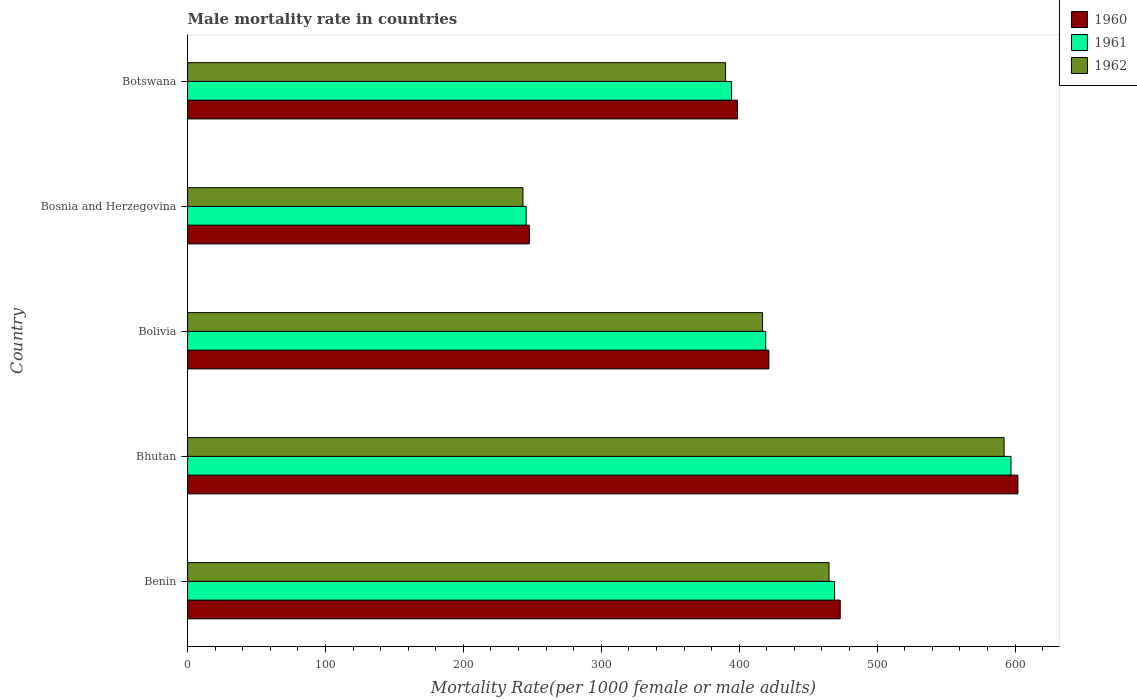Are the number of bars per tick equal to the number of legend labels?
Offer a terse response. Yes. How many bars are there on the 2nd tick from the top?
Ensure brevity in your answer.  3. What is the label of the 3rd group of bars from the top?
Give a very brief answer. Bolivia. What is the male mortality rate in 1961 in Benin?
Offer a terse response. 469.18. Across all countries, what is the maximum male mortality rate in 1961?
Your answer should be very brief. 597.09. Across all countries, what is the minimum male mortality rate in 1961?
Make the answer very short. 245.51. In which country was the male mortality rate in 1961 maximum?
Your response must be concise. Bhutan. In which country was the male mortality rate in 1960 minimum?
Provide a succinct answer. Bosnia and Herzegovina. What is the total male mortality rate in 1962 in the graph?
Your response must be concise. 2107.42. What is the difference between the male mortality rate in 1962 in Bhutan and that in Bolivia?
Provide a succinct answer. 175.15. What is the difference between the male mortality rate in 1960 in Bolivia and the male mortality rate in 1961 in Benin?
Offer a terse response. -47.68. What is the average male mortality rate in 1962 per country?
Provide a short and direct response. 421.48. What is the difference between the male mortality rate in 1962 and male mortality rate in 1960 in Botswana?
Provide a short and direct response. -8.61. What is the ratio of the male mortality rate in 1961 in Bolivia to that in Bosnia and Herzegovina?
Keep it short and to the point. 1.71. Is the difference between the male mortality rate in 1962 in Benin and Bosnia and Herzegovina greater than the difference between the male mortality rate in 1960 in Benin and Bosnia and Herzegovina?
Provide a succinct answer. No. What is the difference between the highest and the second highest male mortality rate in 1962?
Offer a terse response. 126.96. What is the difference between the highest and the lowest male mortality rate in 1960?
Your response must be concise. 354.26. In how many countries, is the male mortality rate in 1961 greater than the average male mortality rate in 1961 taken over all countries?
Provide a short and direct response. 2. What does the 1st bar from the bottom in Bolivia represents?
Give a very brief answer. 1960. How many countries are there in the graph?
Provide a succinct answer. 5. Are the values on the major ticks of X-axis written in scientific E-notation?
Make the answer very short. No. How many legend labels are there?
Provide a succinct answer. 3. What is the title of the graph?
Provide a short and direct response. Male mortality rate in countries. Does "1986" appear as one of the legend labels in the graph?
Give a very brief answer. No. What is the label or title of the X-axis?
Your answer should be very brief. Mortality Rate(per 1000 female or male adults). What is the Mortality Rate(per 1000 female or male adults) in 1960 in Benin?
Offer a terse response. 473.24. What is the Mortality Rate(per 1000 female or male adults) of 1961 in Benin?
Make the answer very short. 469.18. What is the Mortality Rate(per 1000 female or male adults) of 1962 in Benin?
Your answer should be very brief. 465.12. What is the Mortality Rate(per 1000 female or male adults) of 1960 in Bhutan?
Offer a very short reply. 602.1. What is the Mortality Rate(per 1000 female or male adults) in 1961 in Bhutan?
Keep it short and to the point. 597.09. What is the Mortality Rate(per 1000 female or male adults) in 1962 in Bhutan?
Give a very brief answer. 592.08. What is the Mortality Rate(per 1000 female or male adults) in 1960 in Bolivia?
Your answer should be very brief. 421.5. What is the Mortality Rate(per 1000 female or male adults) of 1961 in Bolivia?
Keep it short and to the point. 419.21. What is the Mortality Rate(per 1000 female or male adults) in 1962 in Bolivia?
Ensure brevity in your answer.  416.93. What is the Mortality Rate(per 1000 female or male adults) of 1960 in Bosnia and Herzegovina?
Provide a short and direct response. 247.84. What is the Mortality Rate(per 1000 female or male adults) of 1961 in Bosnia and Herzegovina?
Give a very brief answer. 245.51. What is the Mortality Rate(per 1000 female or male adults) of 1962 in Bosnia and Herzegovina?
Your response must be concise. 243.18. What is the Mortality Rate(per 1000 female or male adults) in 1960 in Botswana?
Your response must be concise. 398.72. What is the Mortality Rate(per 1000 female or male adults) of 1961 in Botswana?
Provide a succinct answer. 394.41. What is the Mortality Rate(per 1000 female or male adults) in 1962 in Botswana?
Provide a short and direct response. 390.11. Across all countries, what is the maximum Mortality Rate(per 1000 female or male adults) in 1960?
Give a very brief answer. 602.1. Across all countries, what is the maximum Mortality Rate(per 1000 female or male adults) in 1961?
Give a very brief answer. 597.09. Across all countries, what is the maximum Mortality Rate(per 1000 female or male adults) in 1962?
Provide a short and direct response. 592.08. Across all countries, what is the minimum Mortality Rate(per 1000 female or male adults) in 1960?
Your response must be concise. 247.84. Across all countries, what is the minimum Mortality Rate(per 1000 female or male adults) of 1961?
Offer a terse response. 245.51. Across all countries, what is the minimum Mortality Rate(per 1000 female or male adults) in 1962?
Your answer should be compact. 243.18. What is the total Mortality Rate(per 1000 female or male adults) of 1960 in the graph?
Your answer should be very brief. 2143.39. What is the total Mortality Rate(per 1000 female or male adults) of 1961 in the graph?
Offer a very short reply. 2125.41. What is the total Mortality Rate(per 1000 female or male adults) of 1962 in the graph?
Keep it short and to the point. 2107.42. What is the difference between the Mortality Rate(per 1000 female or male adults) in 1960 in Benin and that in Bhutan?
Keep it short and to the point. -128.86. What is the difference between the Mortality Rate(per 1000 female or male adults) in 1961 in Benin and that in Bhutan?
Your answer should be very brief. -127.91. What is the difference between the Mortality Rate(per 1000 female or male adults) in 1962 in Benin and that in Bhutan?
Offer a very short reply. -126.96. What is the difference between the Mortality Rate(per 1000 female or male adults) of 1960 in Benin and that in Bolivia?
Give a very brief answer. 51.73. What is the difference between the Mortality Rate(per 1000 female or male adults) in 1961 in Benin and that in Bolivia?
Your answer should be compact. 49.97. What is the difference between the Mortality Rate(per 1000 female or male adults) in 1962 in Benin and that in Bolivia?
Your answer should be very brief. 48.2. What is the difference between the Mortality Rate(per 1000 female or male adults) of 1960 in Benin and that in Bosnia and Herzegovina?
Your answer should be compact. 225.4. What is the difference between the Mortality Rate(per 1000 female or male adults) of 1961 in Benin and that in Bosnia and Herzegovina?
Give a very brief answer. 223.67. What is the difference between the Mortality Rate(per 1000 female or male adults) of 1962 in Benin and that in Bosnia and Herzegovina?
Make the answer very short. 221.94. What is the difference between the Mortality Rate(per 1000 female or male adults) of 1960 in Benin and that in Botswana?
Offer a very short reply. 74.52. What is the difference between the Mortality Rate(per 1000 female or male adults) of 1961 in Benin and that in Botswana?
Make the answer very short. 74.77. What is the difference between the Mortality Rate(per 1000 female or male adults) of 1962 in Benin and that in Botswana?
Your answer should be compact. 75.02. What is the difference between the Mortality Rate(per 1000 female or male adults) of 1960 in Bhutan and that in Bolivia?
Keep it short and to the point. 180.59. What is the difference between the Mortality Rate(per 1000 female or male adults) in 1961 in Bhutan and that in Bolivia?
Your answer should be very brief. 177.87. What is the difference between the Mortality Rate(per 1000 female or male adults) of 1962 in Bhutan and that in Bolivia?
Your response must be concise. 175.15. What is the difference between the Mortality Rate(per 1000 female or male adults) of 1960 in Bhutan and that in Bosnia and Herzegovina?
Provide a succinct answer. 354.26. What is the difference between the Mortality Rate(per 1000 female or male adults) in 1961 in Bhutan and that in Bosnia and Herzegovina?
Your answer should be very brief. 351.58. What is the difference between the Mortality Rate(per 1000 female or male adults) of 1962 in Bhutan and that in Bosnia and Herzegovina?
Offer a very short reply. 348.9. What is the difference between the Mortality Rate(per 1000 female or male adults) in 1960 in Bhutan and that in Botswana?
Provide a short and direct response. 203.38. What is the difference between the Mortality Rate(per 1000 female or male adults) in 1961 in Bhutan and that in Botswana?
Offer a terse response. 202.68. What is the difference between the Mortality Rate(per 1000 female or male adults) of 1962 in Bhutan and that in Botswana?
Your response must be concise. 201.97. What is the difference between the Mortality Rate(per 1000 female or male adults) in 1960 in Bolivia and that in Bosnia and Herzegovina?
Ensure brevity in your answer.  173.66. What is the difference between the Mortality Rate(per 1000 female or male adults) in 1961 in Bolivia and that in Bosnia and Herzegovina?
Give a very brief answer. 173.71. What is the difference between the Mortality Rate(per 1000 female or male adults) of 1962 in Bolivia and that in Bosnia and Herzegovina?
Ensure brevity in your answer.  173.75. What is the difference between the Mortality Rate(per 1000 female or male adults) in 1960 in Bolivia and that in Botswana?
Offer a very short reply. 22.79. What is the difference between the Mortality Rate(per 1000 female or male adults) in 1961 in Bolivia and that in Botswana?
Your response must be concise. 24.8. What is the difference between the Mortality Rate(per 1000 female or male adults) of 1962 in Bolivia and that in Botswana?
Make the answer very short. 26.82. What is the difference between the Mortality Rate(per 1000 female or male adults) in 1960 in Bosnia and Herzegovina and that in Botswana?
Give a very brief answer. -150.88. What is the difference between the Mortality Rate(per 1000 female or male adults) of 1961 in Bosnia and Herzegovina and that in Botswana?
Your response must be concise. -148.9. What is the difference between the Mortality Rate(per 1000 female or male adults) of 1962 in Bosnia and Herzegovina and that in Botswana?
Offer a terse response. -146.93. What is the difference between the Mortality Rate(per 1000 female or male adults) in 1960 in Benin and the Mortality Rate(per 1000 female or male adults) in 1961 in Bhutan?
Ensure brevity in your answer.  -123.85. What is the difference between the Mortality Rate(per 1000 female or male adults) of 1960 in Benin and the Mortality Rate(per 1000 female or male adults) of 1962 in Bhutan?
Offer a terse response. -118.84. What is the difference between the Mortality Rate(per 1000 female or male adults) of 1961 in Benin and the Mortality Rate(per 1000 female or male adults) of 1962 in Bhutan?
Give a very brief answer. -122.9. What is the difference between the Mortality Rate(per 1000 female or male adults) of 1960 in Benin and the Mortality Rate(per 1000 female or male adults) of 1961 in Bolivia?
Provide a short and direct response. 54.02. What is the difference between the Mortality Rate(per 1000 female or male adults) in 1960 in Benin and the Mortality Rate(per 1000 female or male adults) in 1962 in Bolivia?
Make the answer very short. 56.31. What is the difference between the Mortality Rate(per 1000 female or male adults) of 1961 in Benin and the Mortality Rate(per 1000 female or male adults) of 1962 in Bolivia?
Your answer should be compact. 52.25. What is the difference between the Mortality Rate(per 1000 female or male adults) of 1960 in Benin and the Mortality Rate(per 1000 female or male adults) of 1961 in Bosnia and Herzegovina?
Keep it short and to the point. 227.73. What is the difference between the Mortality Rate(per 1000 female or male adults) of 1960 in Benin and the Mortality Rate(per 1000 female or male adults) of 1962 in Bosnia and Herzegovina?
Your answer should be compact. 230.06. What is the difference between the Mortality Rate(per 1000 female or male adults) of 1961 in Benin and the Mortality Rate(per 1000 female or male adults) of 1962 in Bosnia and Herzegovina?
Give a very brief answer. 226. What is the difference between the Mortality Rate(per 1000 female or male adults) of 1960 in Benin and the Mortality Rate(per 1000 female or male adults) of 1961 in Botswana?
Your response must be concise. 78.83. What is the difference between the Mortality Rate(per 1000 female or male adults) in 1960 in Benin and the Mortality Rate(per 1000 female or male adults) in 1962 in Botswana?
Your answer should be compact. 83.13. What is the difference between the Mortality Rate(per 1000 female or male adults) of 1961 in Benin and the Mortality Rate(per 1000 female or male adults) of 1962 in Botswana?
Offer a terse response. 79.07. What is the difference between the Mortality Rate(per 1000 female or male adults) of 1960 in Bhutan and the Mortality Rate(per 1000 female or male adults) of 1961 in Bolivia?
Keep it short and to the point. 182.88. What is the difference between the Mortality Rate(per 1000 female or male adults) in 1960 in Bhutan and the Mortality Rate(per 1000 female or male adults) in 1962 in Bolivia?
Ensure brevity in your answer.  185.17. What is the difference between the Mortality Rate(per 1000 female or male adults) of 1961 in Bhutan and the Mortality Rate(per 1000 female or male adults) of 1962 in Bolivia?
Your answer should be very brief. 180.16. What is the difference between the Mortality Rate(per 1000 female or male adults) in 1960 in Bhutan and the Mortality Rate(per 1000 female or male adults) in 1961 in Bosnia and Herzegovina?
Ensure brevity in your answer.  356.59. What is the difference between the Mortality Rate(per 1000 female or male adults) of 1960 in Bhutan and the Mortality Rate(per 1000 female or male adults) of 1962 in Bosnia and Herzegovina?
Give a very brief answer. 358.92. What is the difference between the Mortality Rate(per 1000 female or male adults) of 1961 in Bhutan and the Mortality Rate(per 1000 female or male adults) of 1962 in Bosnia and Herzegovina?
Give a very brief answer. 353.91. What is the difference between the Mortality Rate(per 1000 female or male adults) in 1960 in Bhutan and the Mortality Rate(per 1000 female or male adults) in 1961 in Botswana?
Offer a terse response. 207.69. What is the difference between the Mortality Rate(per 1000 female or male adults) of 1960 in Bhutan and the Mortality Rate(per 1000 female or male adults) of 1962 in Botswana?
Make the answer very short. 211.99. What is the difference between the Mortality Rate(per 1000 female or male adults) in 1961 in Bhutan and the Mortality Rate(per 1000 female or male adults) in 1962 in Botswana?
Your response must be concise. 206.98. What is the difference between the Mortality Rate(per 1000 female or male adults) in 1960 in Bolivia and the Mortality Rate(per 1000 female or male adults) in 1961 in Bosnia and Herzegovina?
Your answer should be compact. 176. What is the difference between the Mortality Rate(per 1000 female or male adults) in 1960 in Bolivia and the Mortality Rate(per 1000 female or male adults) in 1962 in Bosnia and Herzegovina?
Give a very brief answer. 178.32. What is the difference between the Mortality Rate(per 1000 female or male adults) in 1961 in Bolivia and the Mortality Rate(per 1000 female or male adults) in 1962 in Bosnia and Herzegovina?
Your response must be concise. 176.04. What is the difference between the Mortality Rate(per 1000 female or male adults) of 1960 in Bolivia and the Mortality Rate(per 1000 female or male adults) of 1961 in Botswana?
Make the answer very short. 27.09. What is the difference between the Mortality Rate(per 1000 female or male adults) in 1960 in Bolivia and the Mortality Rate(per 1000 female or male adults) in 1962 in Botswana?
Make the answer very short. 31.4. What is the difference between the Mortality Rate(per 1000 female or male adults) of 1961 in Bolivia and the Mortality Rate(per 1000 female or male adults) of 1962 in Botswana?
Provide a short and direct response. 29.11. What is the difference between the Mortality Rate(per 1000 female or male adults) of 1960 in Bosnia and Herzegovina and the Mortality Rate(per 1000 female or male adults) of 1961 in Botswana?
Provide a succinct answer. -146.57. What is the difference between the Mortality Rate(per 1000 female or male adults) of 1960 in Bosnia and Herzegovina and the Mortality Rate(per 1000 female or male adults) of 1962 in Botswana?
Provide a succinct answer. -142.27. What is the difference between the Mortality Rate(per 1000 female or male adults) of 1961 in Bosnia and Herzegovina and the Mortality Rate(per 1000 female or male adults) of 1962 in Botswana?
Give a very brief answer. -144.6. What is the average Mortality Rate(per 1000 female or male adults) of 1960 per country?
Ensure brevity in your answer.  428.68. What is the average Mortality Rate(per 1000 female or male adults) of 1961 per country?
Your response must be concise. 425.08. What is the average Mortality Rate(per 1000 female or male adults) in 1962 per country?
Keep it short and to the point. 421.48. What is the difference between the Mortality Rate(per 1000 female or male adults) in 1960 and Mortality Rate(per 1000 female or male adults) in 1961 in Benin?
Provide a short and direct response. 4.06. What is the difference between the Mortality Rate(per 1000 female or male adults) in 1960 and Mortality Rate(per 1000 female or male adults) in 1962 in Benin?
Offer a very short reply. 8.11. What is the difference between the Mortality Rate(per 1000 female or male adults) in 1961 and Mortality Rate(per 1000 female or male adults) in 1962 in Benin?
Offer a very short reply. 4.06. What is the difference between the Mortality Rate(per 1000 female or male adults) in 1960 and Mortality Rate(per 1000 female or male adults) in 1961 in Bhutan?
Ensure brevity in your answer.  5.01. What is the difference between the Mortality Rate(per 1000 female or male adults) in 1960 and Mortality Rate(per 1000 female or male adults) in 1962 in Bhutan?
Your response must be concise. 10.02. What is the difference between the Mortality Rate(per 1000 female or male adults) of 1961 and Mortality Rate(per 1000 female or male adults) of 1962 in Bhutan?
Ensure brevity in your answer.  5.01. What is the difference between the Mortality Rate(per 1000 female or male adults) of 1960 and Mortality Rate(per 1000 female or male adults) of 1961 in Bolivia?
Provide a succinct answer. 2.29. What is the difference between the Mortality Rate(per 1000 female or male adults) of 1960 and Mortality Rate(per 1000 female or male adults) of 1962 in Bolivia?
Offer a very short reply. 4.58. What is the difference between the Mortality Rate(per 1000 female or male adults) in 1961 and Mortality Rate(per 1000 female or male adults) in 1962 in Bolivia?
Your response must be concise. 2.29. What is the difference between the Mortality Rate(per 1000 female or male adults) of 1960 and Mortality Rate(per 1000 female or male adults) of 1961 in Bosnia and Herzegovina?
Provide a short and direct response. 2.33. What is the difference between the Mortality Rate(per 1000 female or male adults) in 1960 and Mortality Rate(per 1000 female or male adults) in 1962 in Bosnia and Herzegovina?
Offer a terse response. 4.66. What is the difference between the Mortality Rate(per 1000 female or male adults) of 1961 and Mortality Rate(per 1000 female or male adults) of 1962 in Bosnia and Herzegovina?
Make the answer very short. 2.33. What is the difference between the Mortality Rate(per 1000 female or male adults) in 1960 and Mortality Rate(per 1000 female or male adults) in 1961 in Botswana?
Your response must be concise. 4.3. What is the difference between the Mortality Rate(per 1000 female or male adults) in 1960 and Mortality Rate(per 1000 female or male adults) in 1962 in Botswana?
Ensure brevity in your answer.  8.61. What is the difference between the Mortality Rate(per 1000 female or male adults) of 1961 and Mortality Rate(per 1000 female or male adults) of 1962 in Botswana?
Make the answer very short. 4.3. What is the ratio of the Mortality Rate(per 1000 female or male adults) of 1960 in Benin to that in Bhutan?
Make the answer very short. 0.79. What is the ratio of the Mortality Rate(per 1000 female or male adults) of 1961 in Benin to that in Bhutan?
Offer a terse response. 0.79. What is the ratio of the Mortality Rate(per 1000 female or male adults) in 1962 in Benin to that in Bhutan?
Offer a terse response. 0.79. What is the ratio of the Mortality Rate(per 1000 female or male adults) in 1960 in Benin to that in Bolivia?
Offer a very short reply. 1.12. What is the ratio of the Mortality Rate(per 1000 female or male adults) in 1961 in Benin to that in Bolivia?
Keep it short and to the point. 1.12. What is the ratio of the Mortality Rate(per 1000 female or male adults) in 1962 in Benin to that in Bolivia?
Provide a short and direct response. 1.12. What is the ratio of the Mortality Rate(per 1000 female or male adults) of 1960 in Benin to that in Bosnia and Herzegovina?
Offer a terse response. 1.91. What is the ratio of the Mortality Rate(per 1000 female or male adults) in 1961 in Benin to that in Bosnia and Herzegovina?
Offer a very short reply. 1.91. What is the ratio of the Mortality Rate(per 1000 female or male adults) in 1962 in Benin to that in Bosnia and Herzegovina?
Your answer should be compact. 1.91. What is the ratio of the Mortality Rate(per 1000 female or male adults) in 1960 in Benin to that in Botswana?
Provide a short and direct response. 1.19. What is the ratio of the Mortality Rate(per 1000 female or male adults) in 1961 in Benin to that in Botswana?
Offer a terse response. 1.19. What is the ratio of the Mortality Rate(per 1000 female or male adults) in 1962 in Benin to that in Botswana?
Your answer should be very brief. 1.19. What is the ratio of the Mortality Rate(per 1000 female or male adults) of 1960 in Bhutan to that in Bolivia?
Your response must be concise. 1.43. What is the ratio of the Mortality Rate(per 1000 female or male adults) of 1961 in Bhutan to that in Bolivia?
Ensure brevity in your answer.  1.42. What is the ratio of the Mortality Rate(per 1000 female or male adults) of 1962 in Bhutan to that in Bolivia?
Keep it short and to the point. 1.42. What is the ratio of the Mortality Rate(per 1000 female or male adults) in 1960 in Bhutan to that in Bosnia and Herzegovina?
Provide a succinct answer. 2.43. What is the ratio of the Mortality Rate(per 1000 female or male adults) in 1961 in Bhutan to that in Bosnia and Herzegovina?
Offer a very short reply. 2.43. What is the ratio of the Mortality Rate(per 1000 female or male adults) in 1962 in Bhutan to that in Bosnia and Herzegovina?
Offer a terse response. 2.43. What is the ratio of the Mortality Rate(per 1000 female or male adults) of 1960 in Bhutan to that in Botswana?
Give a very brief answer. 1.51. What is the ratio of the Mortality Rate(per 1000 female or male adults) of 1961 in Bhutan to that in Botswana?
Give a very brief answer. 1.51. What is the ratio of the Mortality Rate(per 1000 female or male adults) in 1962 in Bhutan to that in Botswana?
Provide a succinct answer. 1.52. What is the ratio of the Mortality Rate(per 1000 female or male adults) in 1960 in Bolivia to that in Bosnia and Herzegovina?
Offer a terse response. 1.7. What is the ratio of the Mortality Rate(per 1000 female or male adults) of 1961 in Bolivia to that in Bosnia and Herzegovina?
Your answer should be very brief. 1.71. What is the ratio of the Mortality Rate(per 1000 female or male adults) in 1962 in Bolivia to that in Bosnia and Herzegovina?
Keep it short and to the point. 1.71. What is the ratio of the Mortality Rate(per 1000 female or male adults) in 1960 in Bolivia to that in Botswana?
Offer a terse response. 1.06. What is the ratio of the Mortality Rate(per 1000 female or male adults) in 1961 in Bolivia to that in Botswana?
Give a very brief answer. 1.06. What is the ratio of the Mortality Rate(per 1000 female or male adults) in 1962 in Bolivia to that in Botswana?
Your answer should be very brief. 1.07. What is the ratio of the Mortality Rate(per 1000 female or male adults) of 1960 in Bosnia and Herzegovina to that in Botswana?
Ensure brevity in your answer.  0.62. What is the ratio of the Mortality Rate(per 1000 female or male adults) of 1961 in Bosnia and Herzegovina to that in Botswana?
Provide a short and direct response. 0.62. What is the ratio of the Mortality Rate(per 1000 female or male adults) in 1962 in Bosnia and Herzegovina to that in Botswana?
Ensure brevity in your answer.  0.62. What is the difference between the highest and the second highest Mortality Rate(per 1000 female or male adults) of 1960?
Your answer should be compact. 128.86. What is the difference between the highest and the second highest Mortality Rate(per 1000 female or male adults) of 1961?
Provide a succinct answer. 127.91. What is the difference between the highest and the second highest Mortality Rate(per 1000 female or male adults) of 1962?
Make the answer very short. 126.96. What is the difference between the highest and the lowest Mortality Rate(per 1000 female or male adults) in 1960?
Keep it short and to the point. 354.26. What is the difference between the highest and the lowest Mortality Rate(per 1000 female or male adults) in 1961?
Your response must be concise. 351.58. What is the difference between the highest and the lowest Mortality Rate(per 1000 female or male adults) of 1962?
Offer a very short reply. 348.9. 